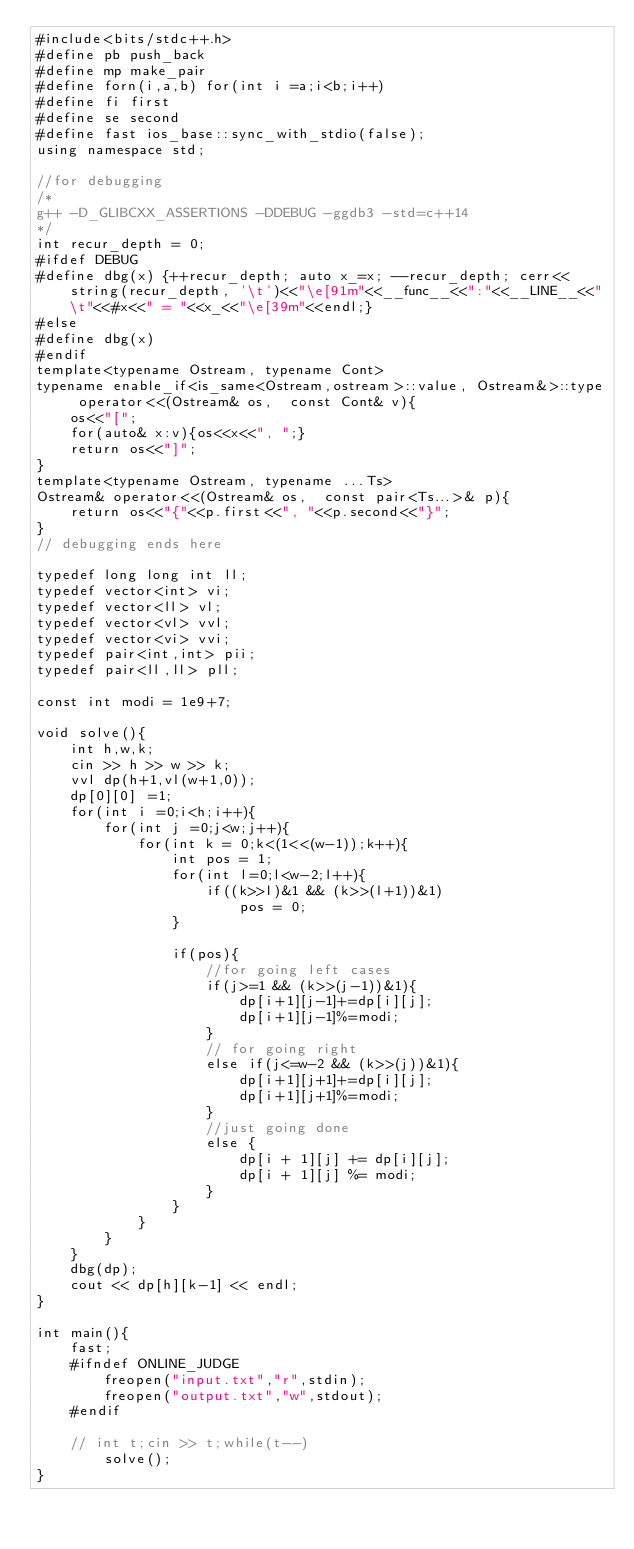Convert code to text. <code><loc_0><loc_0><loc_500><loc_500><_C++_>#include<bits/stdc++.h>
#define pb push_back
#define mp make_pair
#define forn(i,a,b) for(int i =a;i<b;i++)
#define fi first
#define se second
#define fast ios_base::sync_with_stdio(false);
using namespace std;

//for debugging 
/*
g++ -D_GLIBCXX_ASSERTIONS -DDEBUG -ggdb3 -std=c++14 
*/
int recur_depth = 0;
#ifdef DEBUG
#define dbg(x) {++recur_depth; auto x_=x; --recur_depth; cerr<<string(recur_depth, '\t')<<"\e[91m"<<__func__<<":"<<__LINE__<<"\t"<<#x<<" = "<<x_<<"\e[39m"<<endl;}
#else
#define dbg(x)
#endif
template<typename Ostream, typename Cont>
typename enable_if<is_same<Ostream,ostream>::value, Ostream&>::type operator<<(Ostream& os,  const Cont& v){
	os<<"[";
	for(auto& x:v){os<<x<<", ";}
	return os<<"]";
}
template<typename Ostream, typename ...Ts>
Ostream& operator<<(Ostream& os,  const pair<Ts...>& p){
	return os<<"{"<<p.first<<", "<<p.second<<"}";
}
// debugging ends here

typedef long long int ll;
typedef vector<int> vi;
typedef vector<ll> vl;
typedef vector<vl> vvl;
typedef vector<vi> vvi;
typedef pair<int,int> pii;
typedef pair<ll,ll> pll;

const int modi = 1e9+7;

void solve(){
	int h,w,k;
	cin >> h >> w >> k;
	vvl dp(h+1,vl(w+1,0));
	dp[0][0] =1;
	for(int i =0;i<h;i++){
		for(int j =0;j<w;j++){
			for(int k = 0;k<(1<<(w-1));k++){
				int pos = 1;
				for(int l=0;l<w-2;l++){
					if((k>>l)&1 && (k>>(l+1))&1)
						pos = 0;
				}

				if(pos){
					//for going left cases 
					if(j>=1 && (k>>(j-1))&1){
						dp[i+1][j-1]+=dp[i][j];
						dp[i+1][j-1]%=modi;
					}
					// for going right
					else if(j<=w-2 && (k>>(j))&1){
						dp[i+1][j+1]+=dp[i][j];
						dp[i+1][j+1]%=modi;
					}
					//just going done
					else {
						dp[i + 1][j] += dp[i][j];
						dp[i + 1][j] %= modi;
					}
				}
			}
		}
	}
	dbg(dp);
	cout << dp[h][k-1] << endl;
}

int main(){
	fast;
	#ifndef ONLINE_JUDGE
		freopen("input.txt","r",stdin);
		freopen("output.txt","w",stdout);
	#endif

	// int t;cin >> t;while(t--)
		solve();
}
</code> 